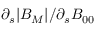Convert formula to latex. <formula><loc_0><loc_0><loc_500><loc_500>\partial _ { s } | B _ { M } | / \partial _ { s } B _ { 0 0 }</formula> 